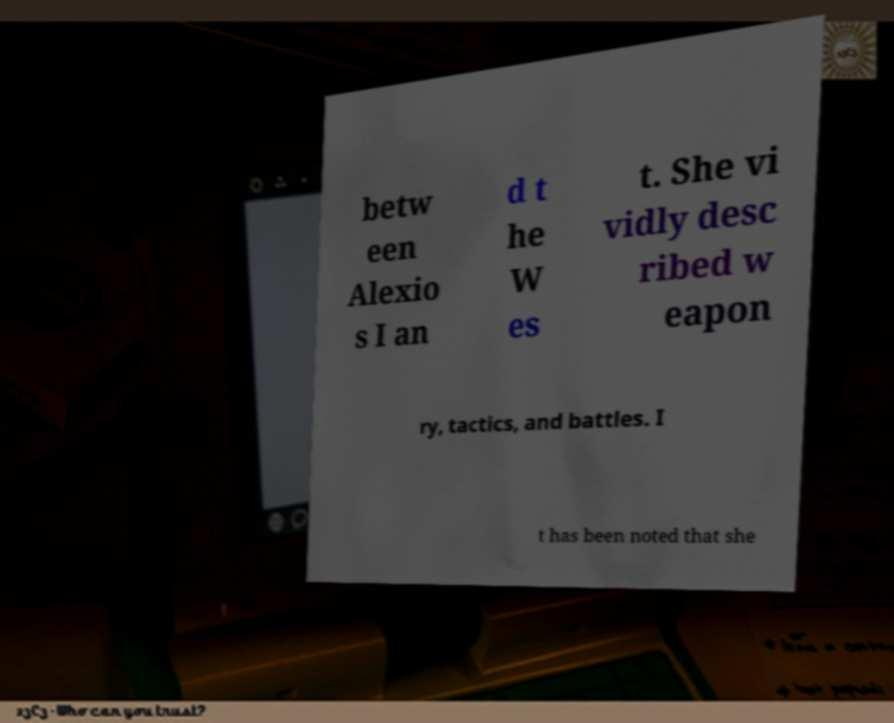Can you accurately transcribe the text from the provided image for me? betw een Alexio s I an d t he W es t. She vi vidly desc ribed w eapon ry, tactics, and battles. I t has been noted that she 